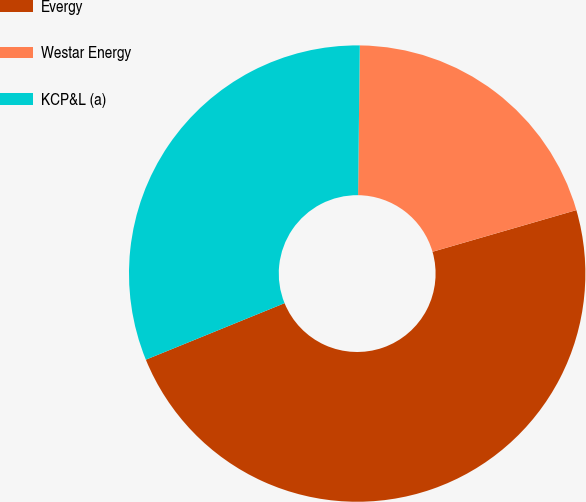Convert chart. <chart><loc_0><loc_0><loc_500><loc_500><pie_chart><fcel>Evergy<fcel>Westar Energy<fcel>KCP&L (a)<nl><fcel>48.33%<fcel>20.33%<fcel>31.34%<nl></chart> 